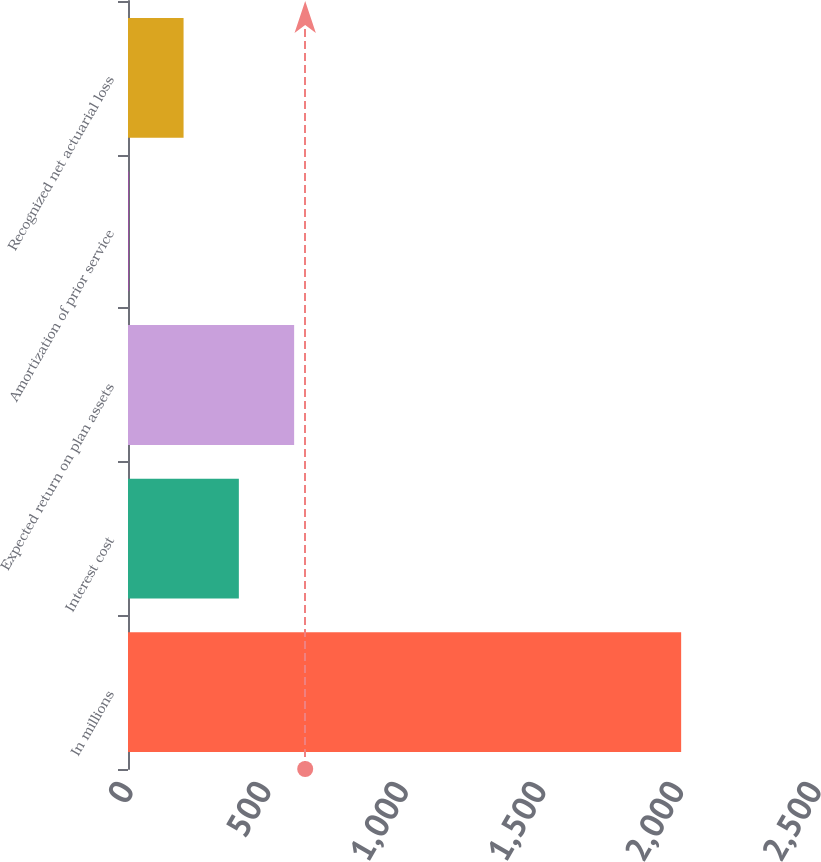<chart> <loc_0><loc_0><loc_500><loc_500><bar_chart><fcel>In millions<fcel>Interest cost<fcel>Expected return on plan assets<fcel>Amortization of prior service<fcel>Recognized net actuarial loss<nl><fcel>2010<fcel>402.8<fcel>603.7<fcel>1<fcel>201.9<nl></chart> 